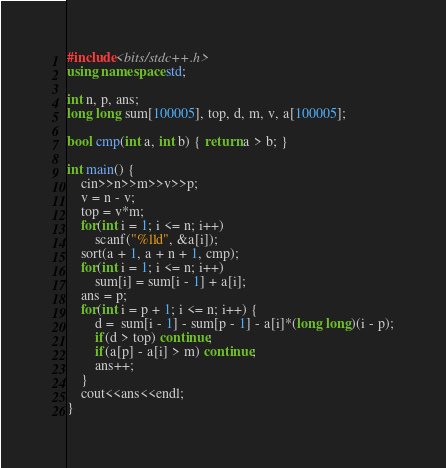Convert code to text. <code><loc_0><loc_0><loc_500><loc_500><_C++_>#include<bits/stdc++.h>
using namespace std;

int n, p, ans;
long long sum[100005], top, d, m, v, a[100005];

bool cmp(int a, int b) { return a > b; }

int main() {
	cin>>n>>m>>v>>p;
	v = n - v;
	top = v*m;
	for(int i = 1; i <= n; i++)
		scanf("%lld", &a[i]);
	sort(a + 1, a + n + 1, cmp);
	for(int i = 1; i <= n; i++)
	    sum[i] = sum[i - 1] + a[i];
	ans = p;
	for(int i = p + 1; i <= n; i++) {
		d =  sum[i - 1] - sum[p - 1] - a[i]*(long long)(i - p);
		if(d > top) continue;
		if(a[p] - a[i] > m) continue;
		ans++;
	}
	cout<<ans<<endl;
} 

</code> 